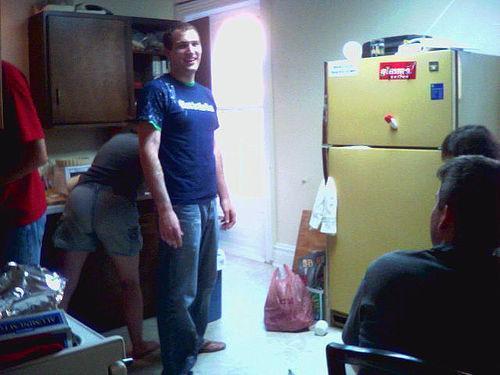How many chairs can be seen?
Give a very brief answer. 2. How many people can you see?
Give a very brief answer. 4. How many ovens are in the picture?
Give a very brief answer. 1. How many baby sheep are there in the image?
Give a very brief answer. 0. 